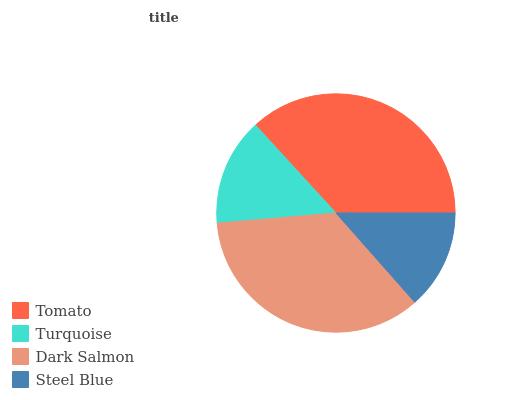Is Steel Blue the minimum?
Answer yes or no. Yes. Is Tomato the maximum?
Answer yes or no. Yes. Is Turquoise the minimum?
Answer yes or no. No. Is Turquoise the maximum?
Answer yes or no. No. Is Tomato greater than Turquoise?
Answer yes or no. Yes. Is Turquoise less than Tomato?
Answer yes or no. Yes. Is Turquoise greater than Tomato?
Answer yes or no. No. Is Tomato less than Turquoise?
Answer yes or no. No. Is Dark Salmon the high median?
Answer yes or no. Yes. Is Turquoise the low median?
Answer yes or no. Yes. Is Tomato the high median?
Answer yes or no. No. Is Steel Blue the low median?
Answer yes or no. No. 